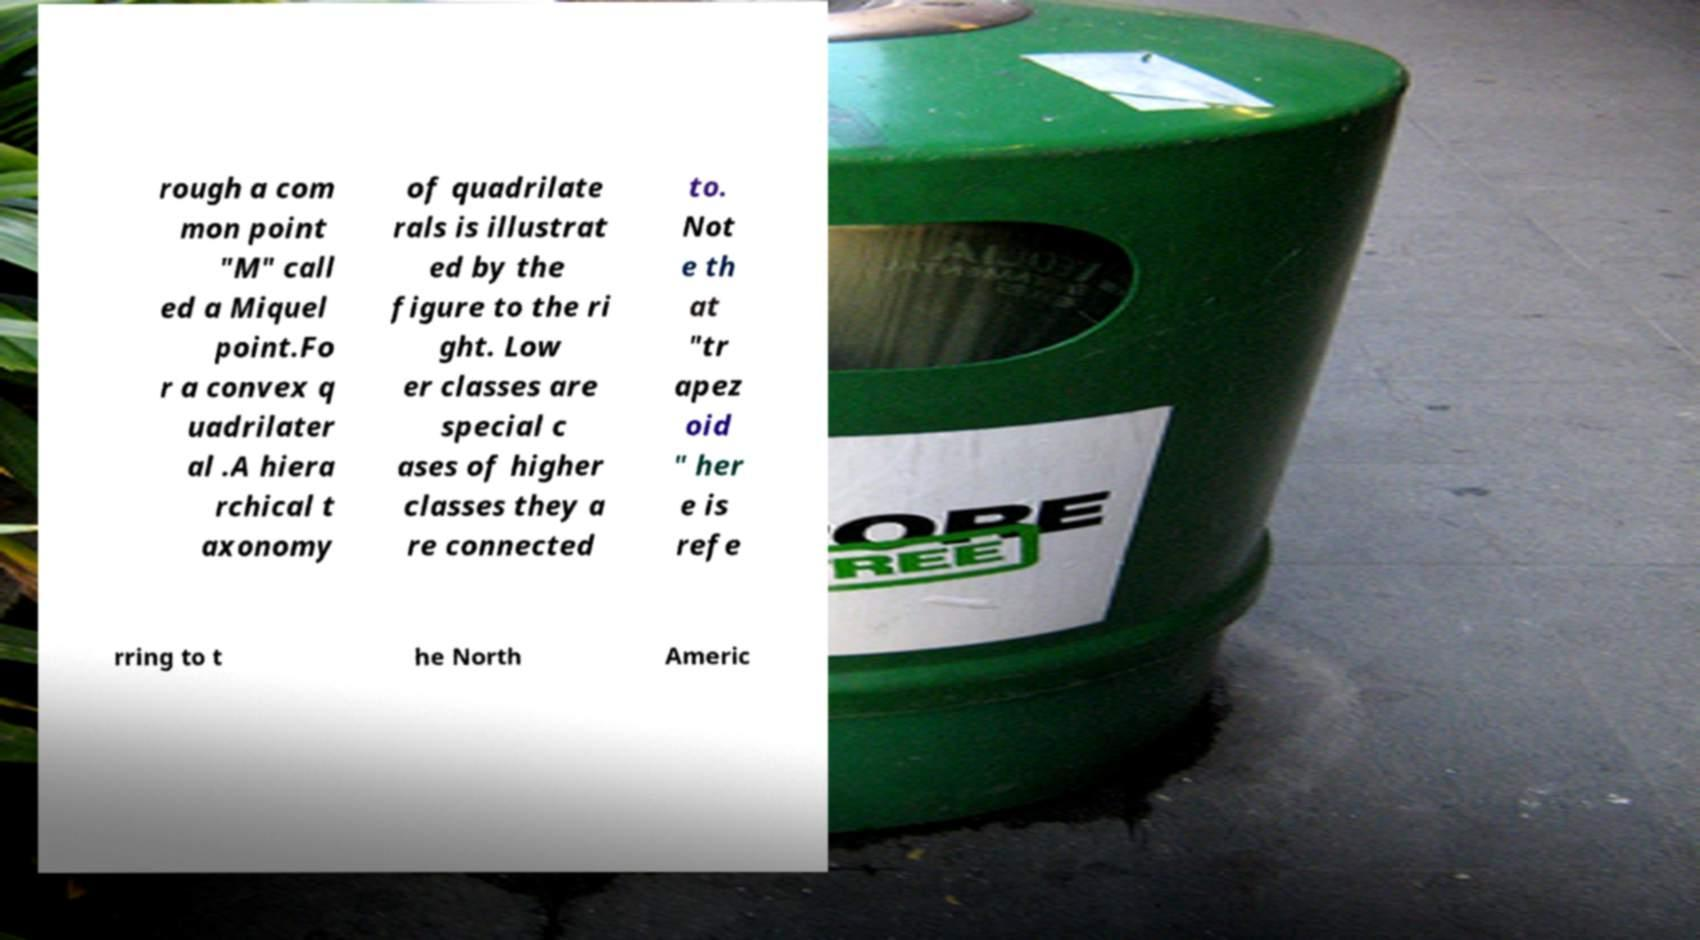Can you read and provide the text displayed in the image?This photo seems to have some interesting text. Can you extract and type it out for me? rough a com mon point "M" call ed a Miquel point.Fo r a convex q uadrilater al .A hiera rchical t axonomy of quadrilate rals is illustrat ed by the figure to the ri ght. Low er classes are special c ases of higher classes they a re connected to. Not e th at "tr apez oid " her e is refe rring to t he North Americ 